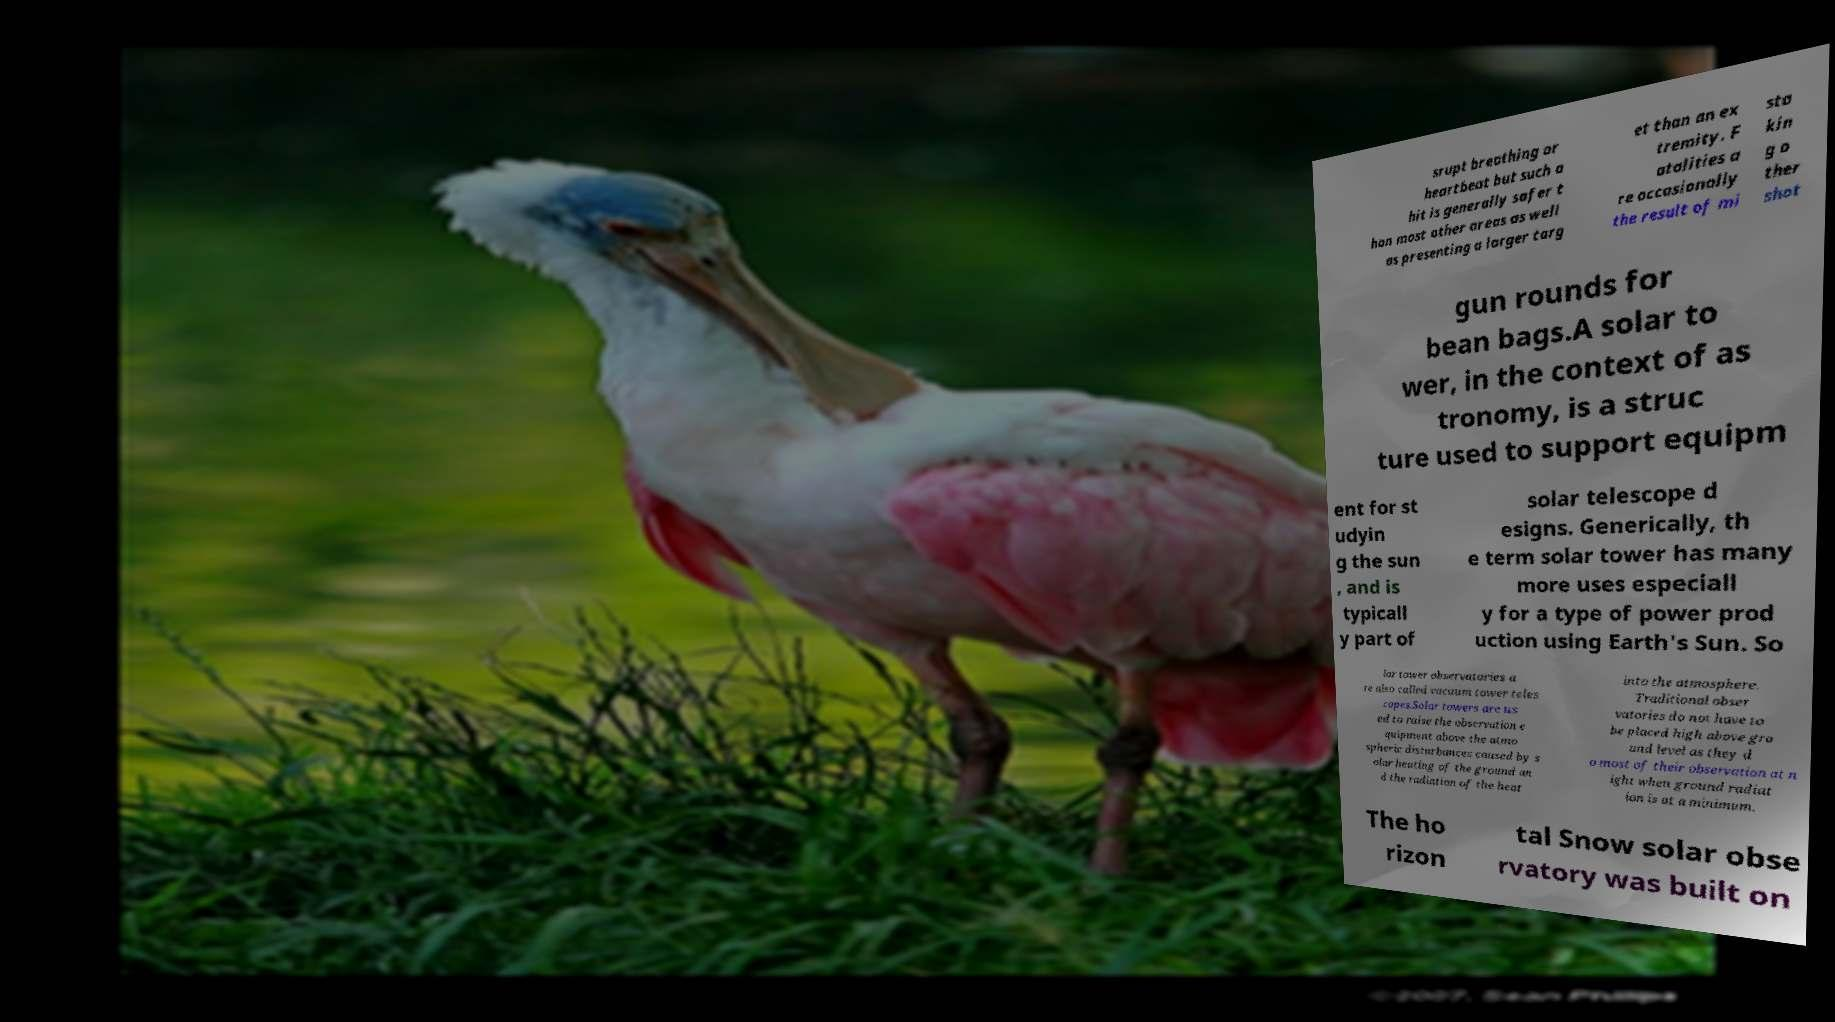What messages or text are displayed in this image? I need them in a readable, typed format. srupt breathing or heartbeat but such a hit is generally safer t han most other areas as well as presenting a larger targ et than an ex tremity. F atalities a re occasionally the result of mi sta kin g o ther shot gun rounds for bean bags.A solar to wer, in the context of as tronomy, is a struc ture used to support equipm ent for st udyin g the sun , and is typicall y part of solar telescope d esigns. Generically, th e term solar tower has many more uses especiall y for a type of power prod uction using Earth's Sun. So lar tower observatories a re also called vacuum tower teles copes.Solar towers are us ed to raise the observation e quipment above the atmo spheric disturbances caused by s olar heating of the ground an d the radiation of the heat into the atmosphere. Traditional obser vatories do not have to be placed high above gro und level as they d o most of their observation at n ight when ground radiat ion is at a minimum. The ho rizon tal Snow solar obse rvatory was built on 